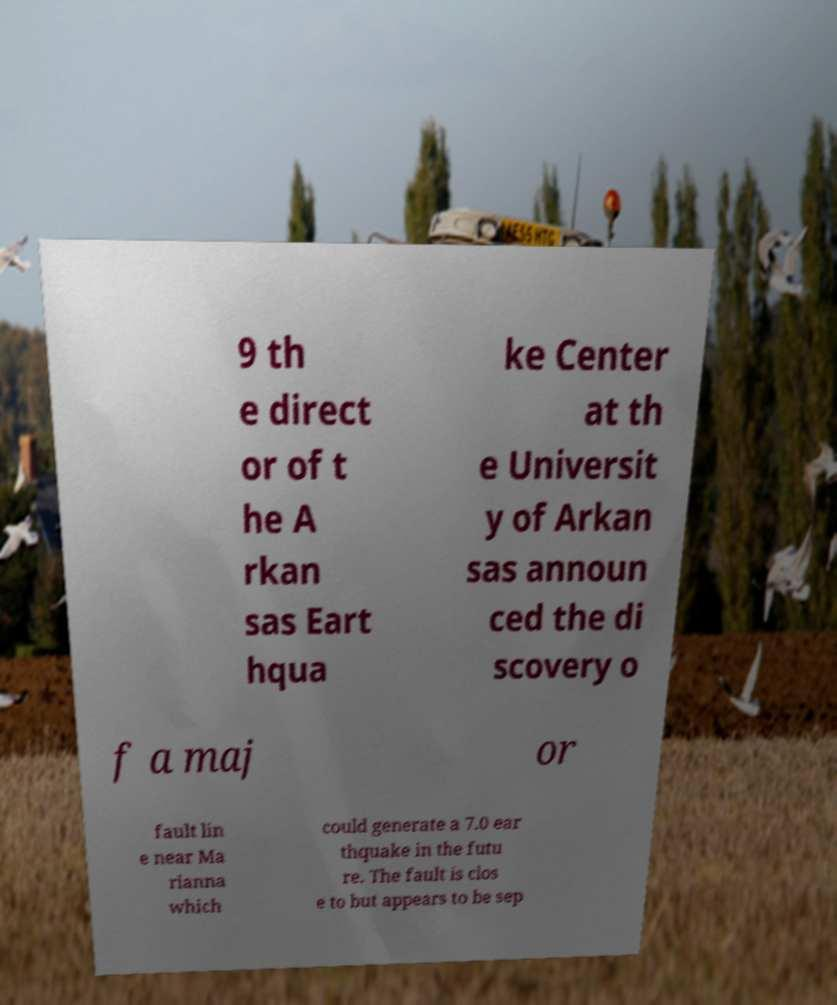For documentation purposes, I need the text within this image transcribed. Could you provide that? 9 th e direct or of t he A rkan sas Eart hqua ke Center at th e Universit y of Arkan sas announ ced the di scovery o f a maj or fault lin e near Ma rianna which could generate a 7.0 ear thquake in the futu re. The fault is clos e to but appears to be sep 